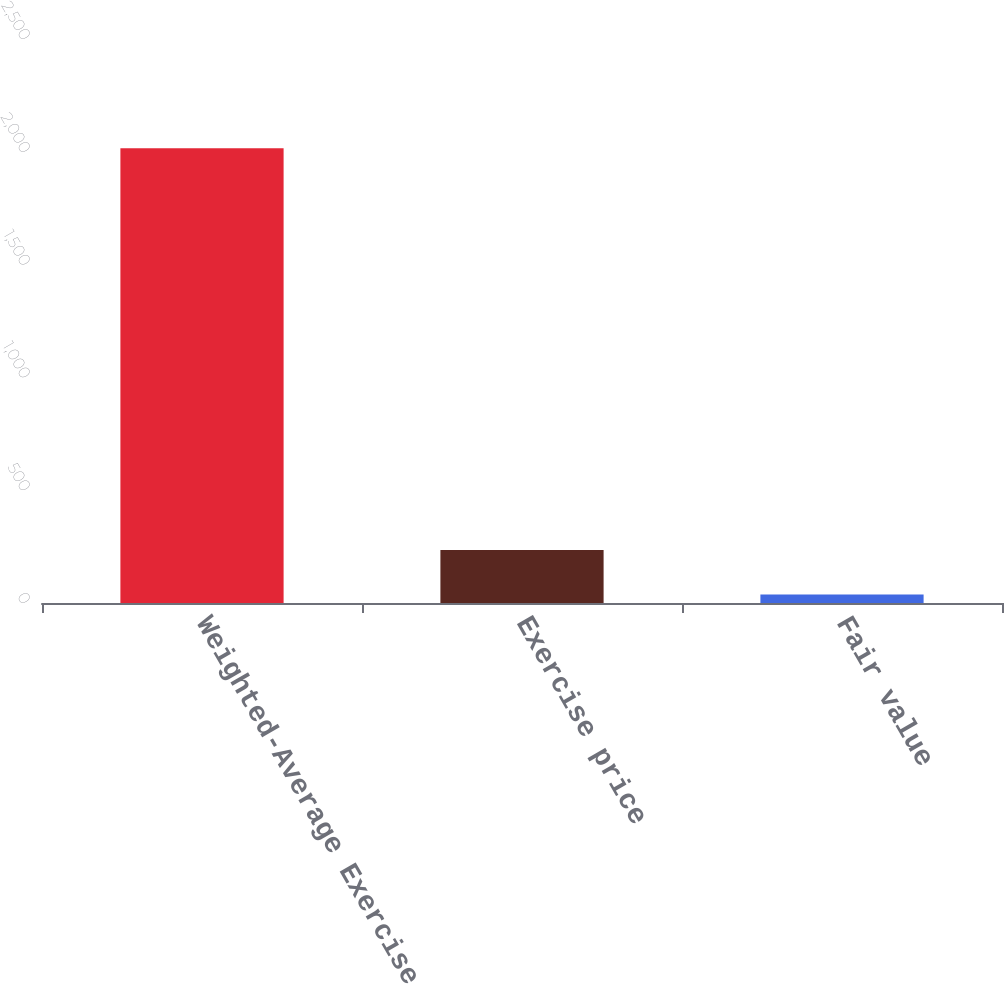<chart> <loc_0><loc_0><loc_500><loc_500><bar_chart><fcel>Weighted-Average Exercise<fcel>Exercise price<fcel>Fair value<nl><fcel>2016<fcel>235.3<fcel>37.44<nl></chart> 